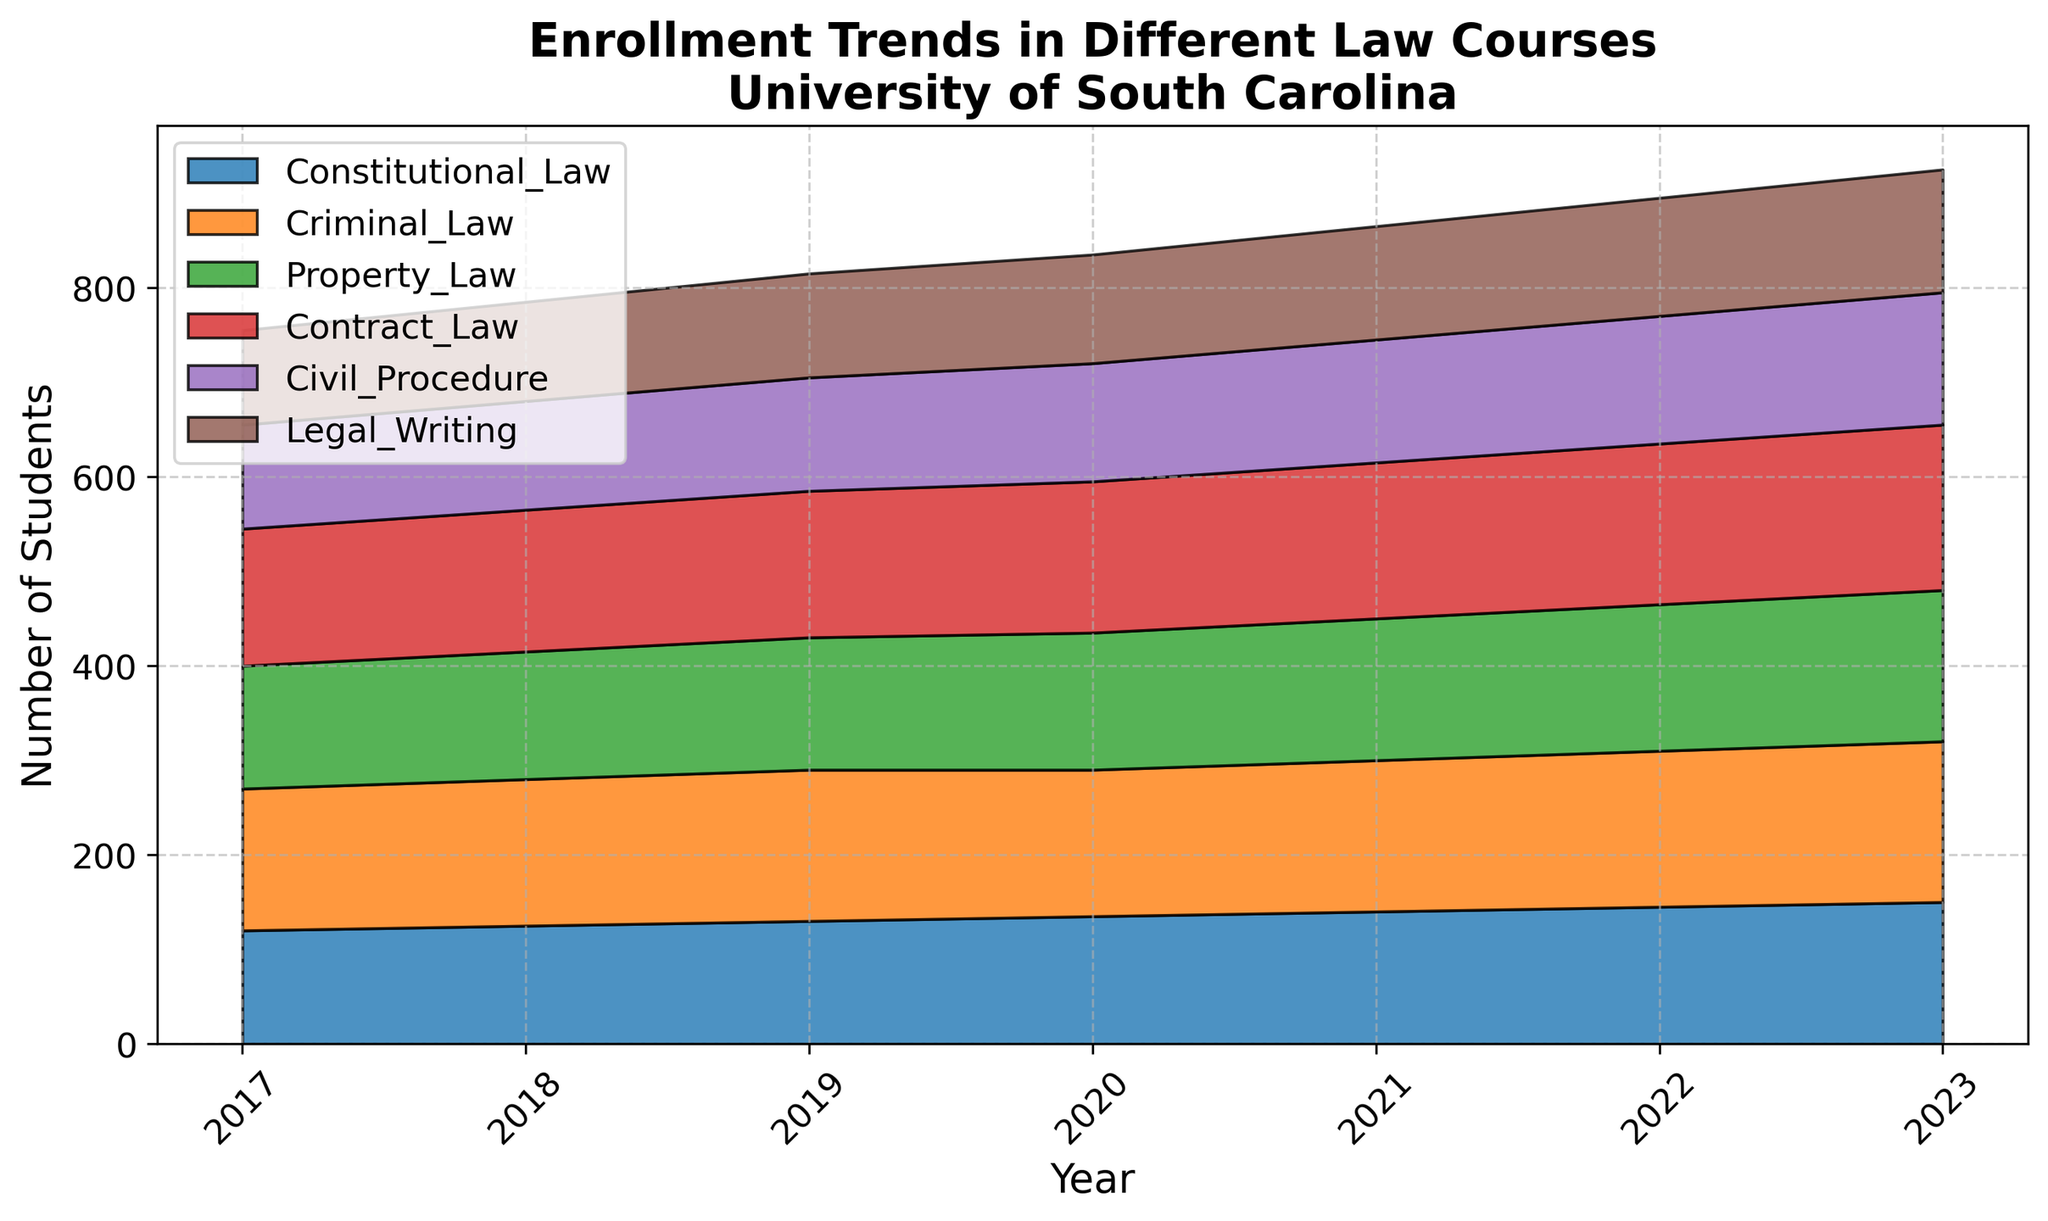What is the trend in enrollment for Constitutional Law from 2017 to 2023? The enrollment for Constitutional Law has increased each year from 120 students in 2017 to 150 students in 2023.
Answer: Constant increase Which course showed the most significant increase in enrollment from 2017 to 2023? By comparing the increase in enrollment for each course, Contract Law increased the most, from 145 students in 2017 to 175 students in 2023, which is an increase of 30 students.
Answer: Contract Law How does the enrollment trend for Criminal Law compare to that for Civil Procedure over the years? The enrollment in Criminal Law increased steadily from 150 in 2017 to 170 in 2023. In contrast, the enrollment in Civil Procedure also increased but to a lesser extent, from 110 in 2017 to 140 in 2023. Criminal Law has a stronger growth rate.
Answer: Criminal Law has a stronger growth rate What is the average enrollment in Legal Writing across the years? To find the average: (100+105+110+115+120+125+130) / 7 = 805 / 7 = ~115
Answer: ~115 Between 2020 and 2021, which course had the smallest change in enrollment? Comparing the changes: Constitutional Law (135 to 140, +5), Criminal Law (155 to 160, +5), Property Law (145 to 150, +5), Contract Law (160 to 165, +5), Civil Procedure (125 to 130, +5), Legal Writing (115 to 120, +5). All courses had the same change of +5.
Answer: All courses How did the total enrollment in all courses combined change from 2017 to 2023? Summing up the enrollments: 2017 (120+150+130+145+110+100 = 755), 2023 (150+170+160+175+140+130 = 925). The total change = 925 - 755 = 170.
Answer: Increased by 170 students Which year had the highest combined enrollment in all courses? By summing the enrollments for each year, 2023 had the highest combined enrollment of 925 students.
Answer: 2023 In which year did Property Law have the same number of enrollments as Legal Writing? Comparing the enrollments year by year, in no year did Property Law have the same number of enrollments as Legal Writing.
Answer: No year If you combine enrollments for Constitutional Law and Criminal Law in 2021, what is the total? The total for 2021 is 140 (Constitutional) + 160 (Criminal) = 300.
Answer: 300 Which course had the most consistent enrollment numbers from 2017 to 2023? Looking at the changes each year, Legal Writing had the most steady and consistent increase.
Answer: Legal Writing 